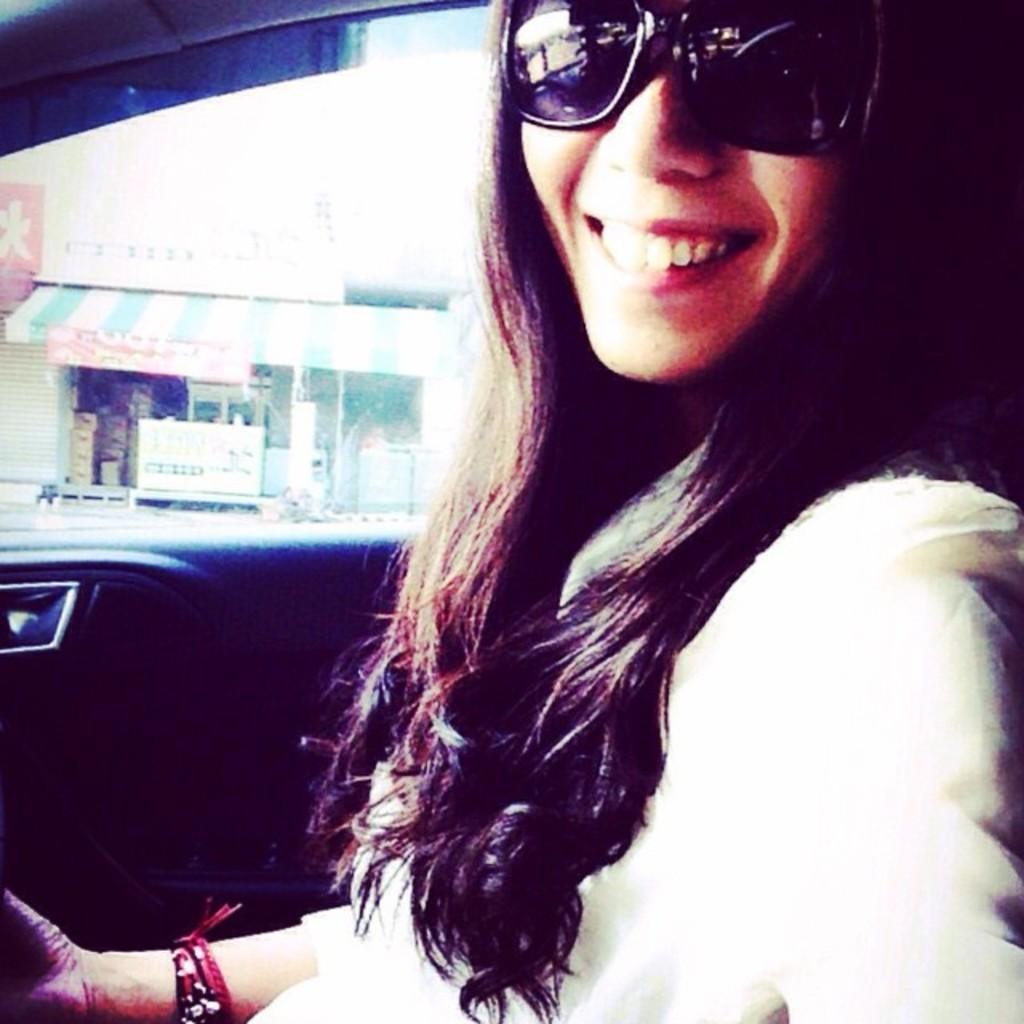Could you give a brief overview of what you see in this image? In the foreground of this image, it seems like there is a woman in a vehicle where we can see the door behind her. In the background, there is a shop, shutter, few boards and few cardboard boxes. 